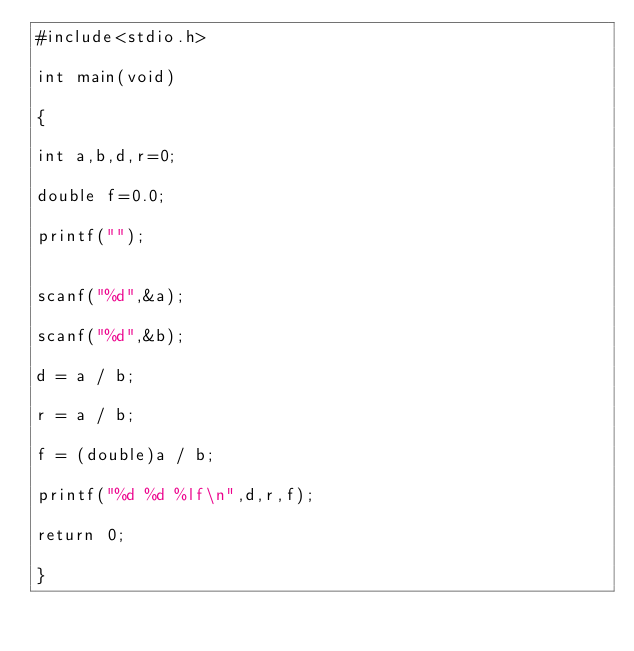Convert code to text. <code><loc_0><loc_0><loc_500><loc_500><_C_>#include<stdio.h>

int main(void)

{

int a,b,d,r=0;

double f=0.0;

printf("");


scanf("%d",&a);

scanf("%d",&b);

d = a / b;

r = a / b;

f = (double)a / b;

printf("%d %d %lf\n",d,r,f);

return 0;

}</code> 